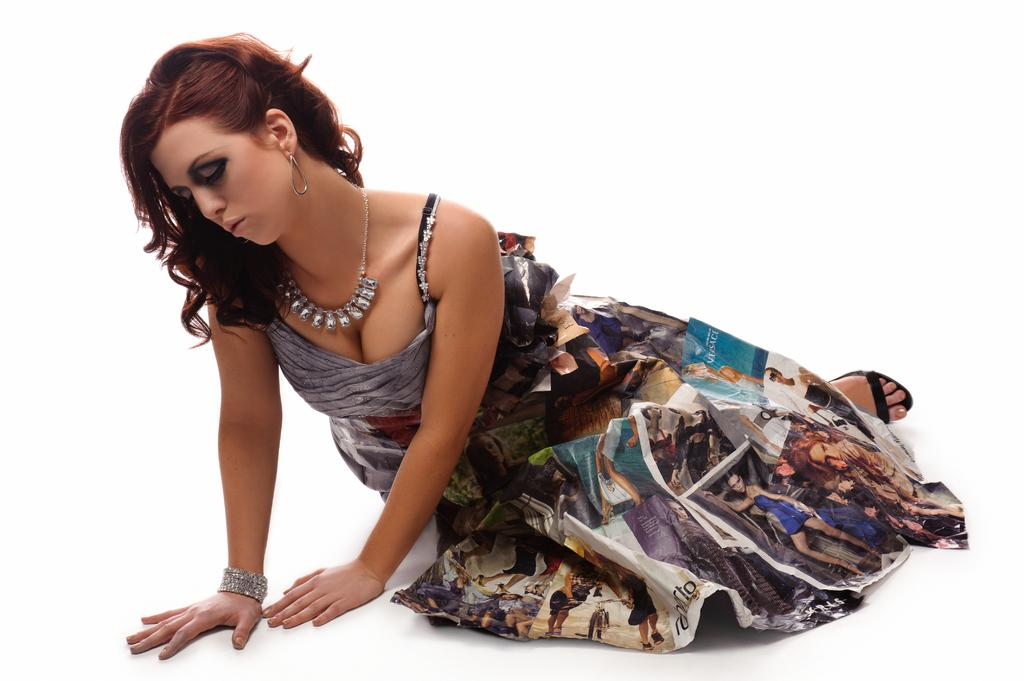Who is the main subject in the image? There is a lady in the center of the image. What type of bomb is present in the image? There is no bomb present in the image; it only features a lady in the center. What kind of loaf is being held by the lady in the image? There is no loaf visible in the image; the lady is the only subject mentioned. 